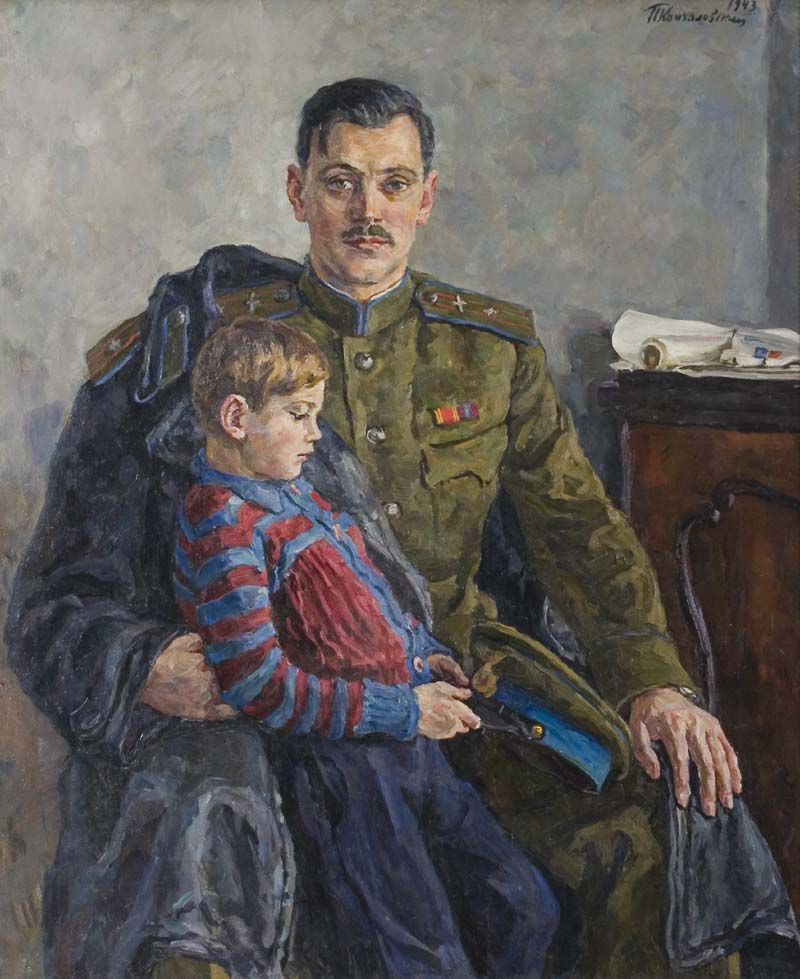Could you write a poem inspired by this painting? In a world of duty's shadow cast,
Where medals speak of battles past,
A soldier's heart finds gentle grace,
In a child’s serene embrace.

Uniform green, a stripe of red,
Stories untold within his head,
Yet in his arms, a boy he holds,
A touch of warmth as day unfolds.

Brushstrokes soft, in hues of grey,
A fleeting glimpse of yesterday,
The canvas whispers tales of love,
Of bonds below and stars above.

Military steel, familial thread,
Life's complexities fondly spread,
In this moment, time stands still,
A soldier's love, unwavering will.

Impressionist hues, emotions blend,
Where duty and affection mend,
A painting’s tale of tender strife,
Of military and a father’s life. 